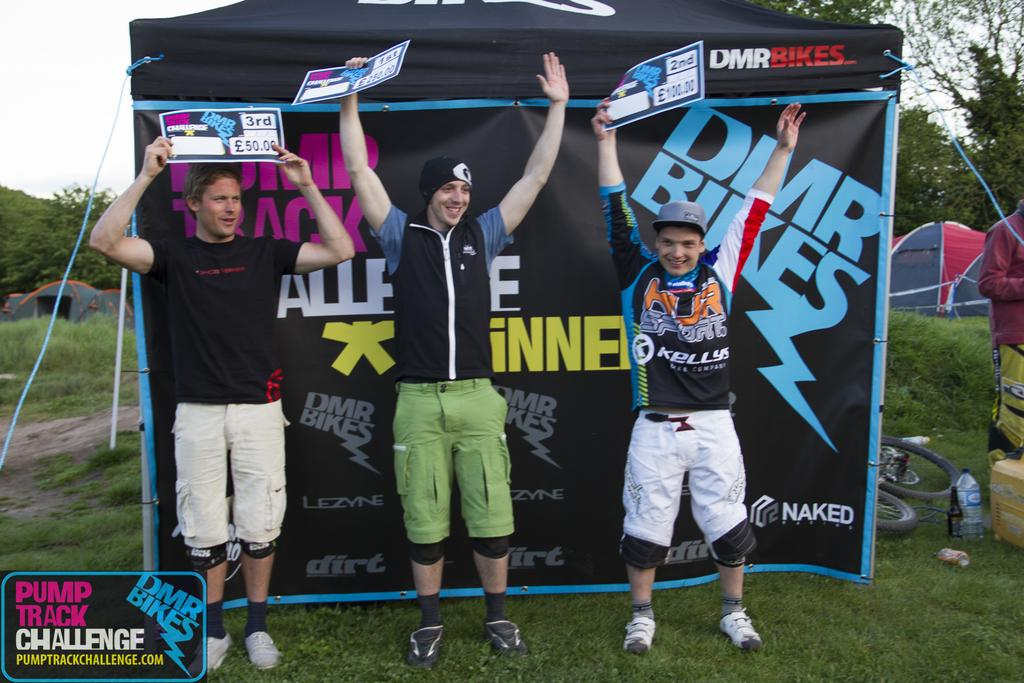<image>
Provide a brief description of the given image. First prize at the Pump Track Challenge won 250 pounds. 